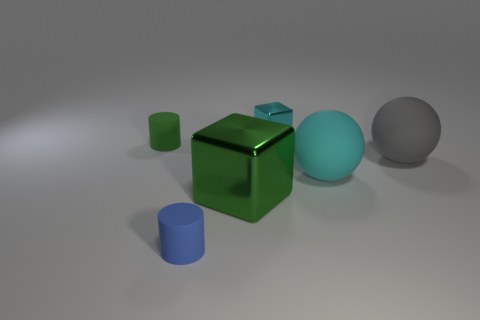Add 1 small green cylinders. How many objects exist? 7 Subtract all cylinders. How many objects are left? 4 Subtract all tiny cubes. Subtract all blue matte objects. How many objects are left? 4 Add 6 small blue things. How many small blue things are left? 7 Add 6 tiny cubes. How many tiny cubes exist? 7 Subtract 0 blue balls. How many objects are left? 6 